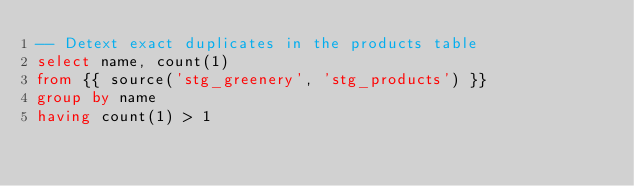<code> <loc_0><loc_0><loc_500><loc_500><_SQL_>-- Detext exact duplicates in the products table
select name, count(1)
from {{ source('stg_greenery', 'stg_products') }}
group by name
having count(1) > 1</code> 